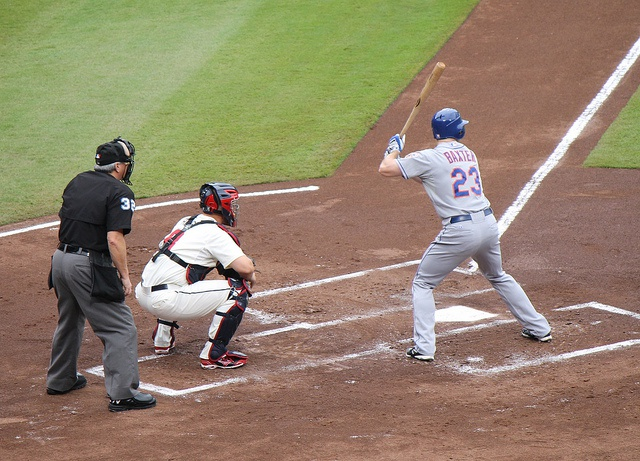Describe the objects in this image and their specific colors. I can see people in olive, black, and gray tones, people in olive, lavender, darkgray, and gray tones, people in olive, white, black, darkgray, and gray tones, and baseball bat in olive, gray, and tan tones in this image. 